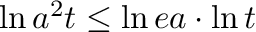<formula> <loc_0><loc_0><loc_500><loc_500>{ \ln { a ^ { 2 } t } } \leq { \ln { e a } } \cdot { \ln { t } }</formula> 